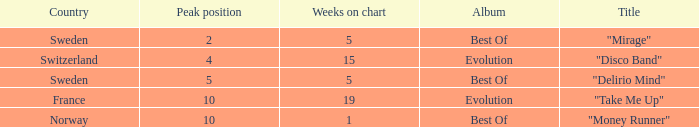What is the title of the single with the peak position of 10 and from France? "Take Me Up". 